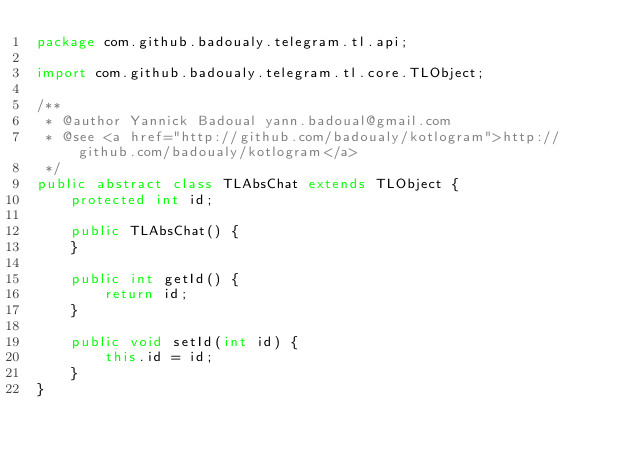<code> <loc_0><loc_0><loc_500><loc_500><_Java_>package com.github.badoualy.telegram.tl.api;

import com.github.badoualy.telegram.tl.core.TLObject;

/**
 * @author Yannick Badoual yann.badoual@gmail.com
 * @see <a href="http://github.com/badoualy/kotlogram">http://github.com/badoualy/kotlogram</a>
 */
public abstract class TLAbsChat extends TLObject {
    protected int id;

    public TLAbsChat() {
    }

    public int getId() {
        return id;
    }

    public void setId(int id) {
        this.id = id;
    }
}
</code> 